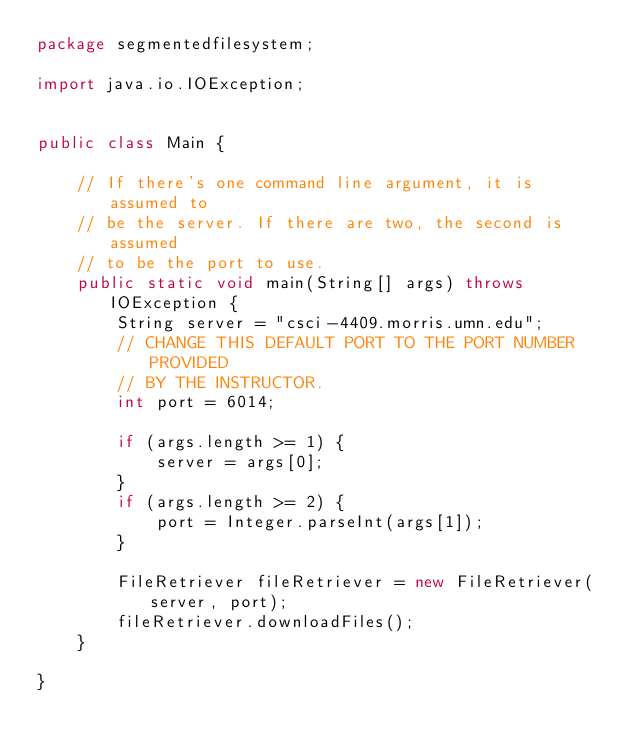Convert code to text. <code><loc_0><loc_0><loc_500><loc_500><_Java_>package segmentedfilesystem;

import java.io.IOException;


public class Main {
    
    // If there's one command line argument, it is assumed to
    // be the server. If there are two, the second is assumed
    // to be the port to use.
    public static void main(String[] args) throws IOException {
        String server = "csci-4409.morris.umn.edu";
        // CHANGE THIS DEFAULT PORT TO THE PORT NUMBER PROVIDED
        // BY THE INSTRUCTOR.
        int port = 6014;
        
        if (args.length >= 1) {
            server = args[0];
        }
        if (args.length >= 2) {
            port = Integer.parseInt(args[1]);
        }

        FileRetriever fileRetriever = new FileRetriever(server, port);
        fileRetriever.downloadFiles();
    }

}
</code> 